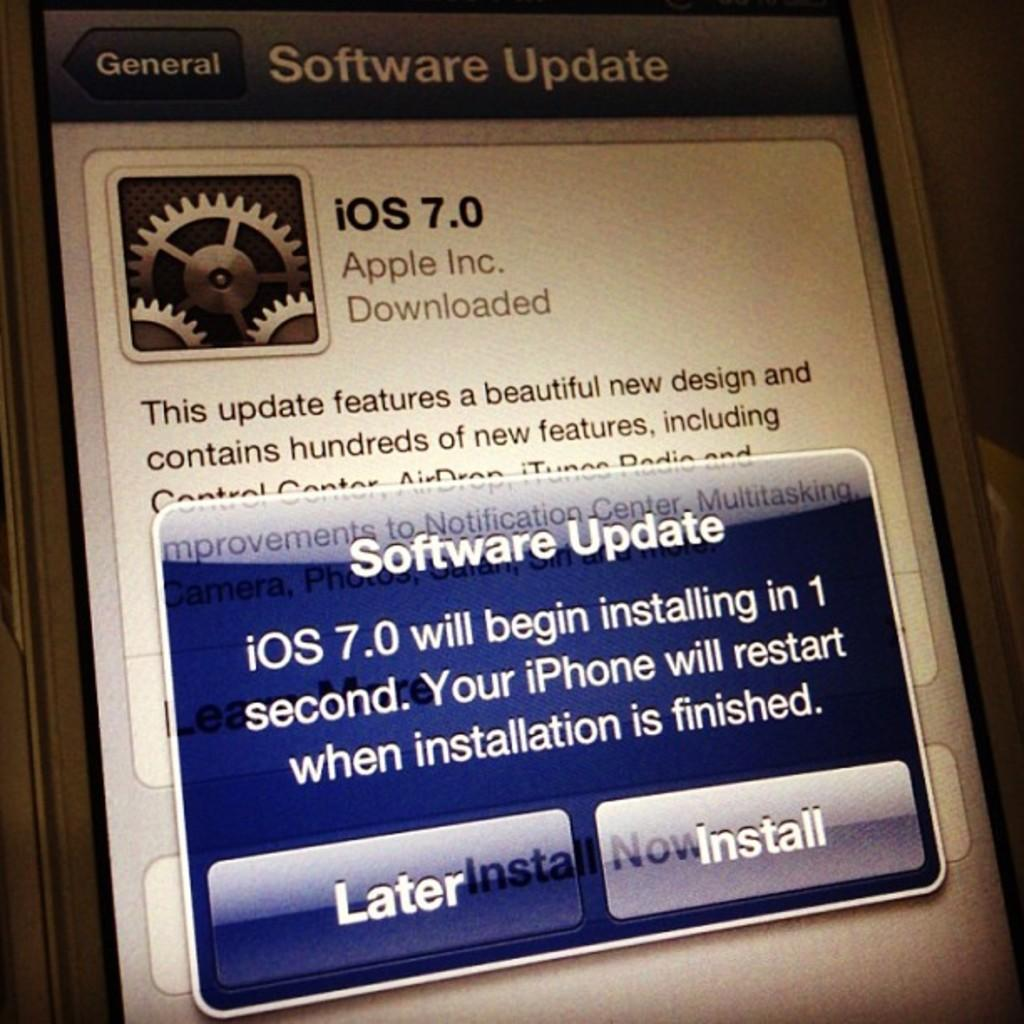<image>
Share a concise interpretation of the image provided. Phone screen showing an update for iOS 7.0. 